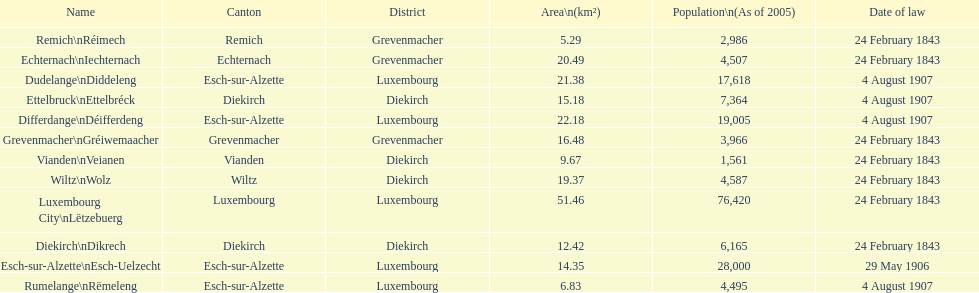Which canton falls under the date of law of 24 february 1843 and has a population of 3,966? Grevenmacher. 